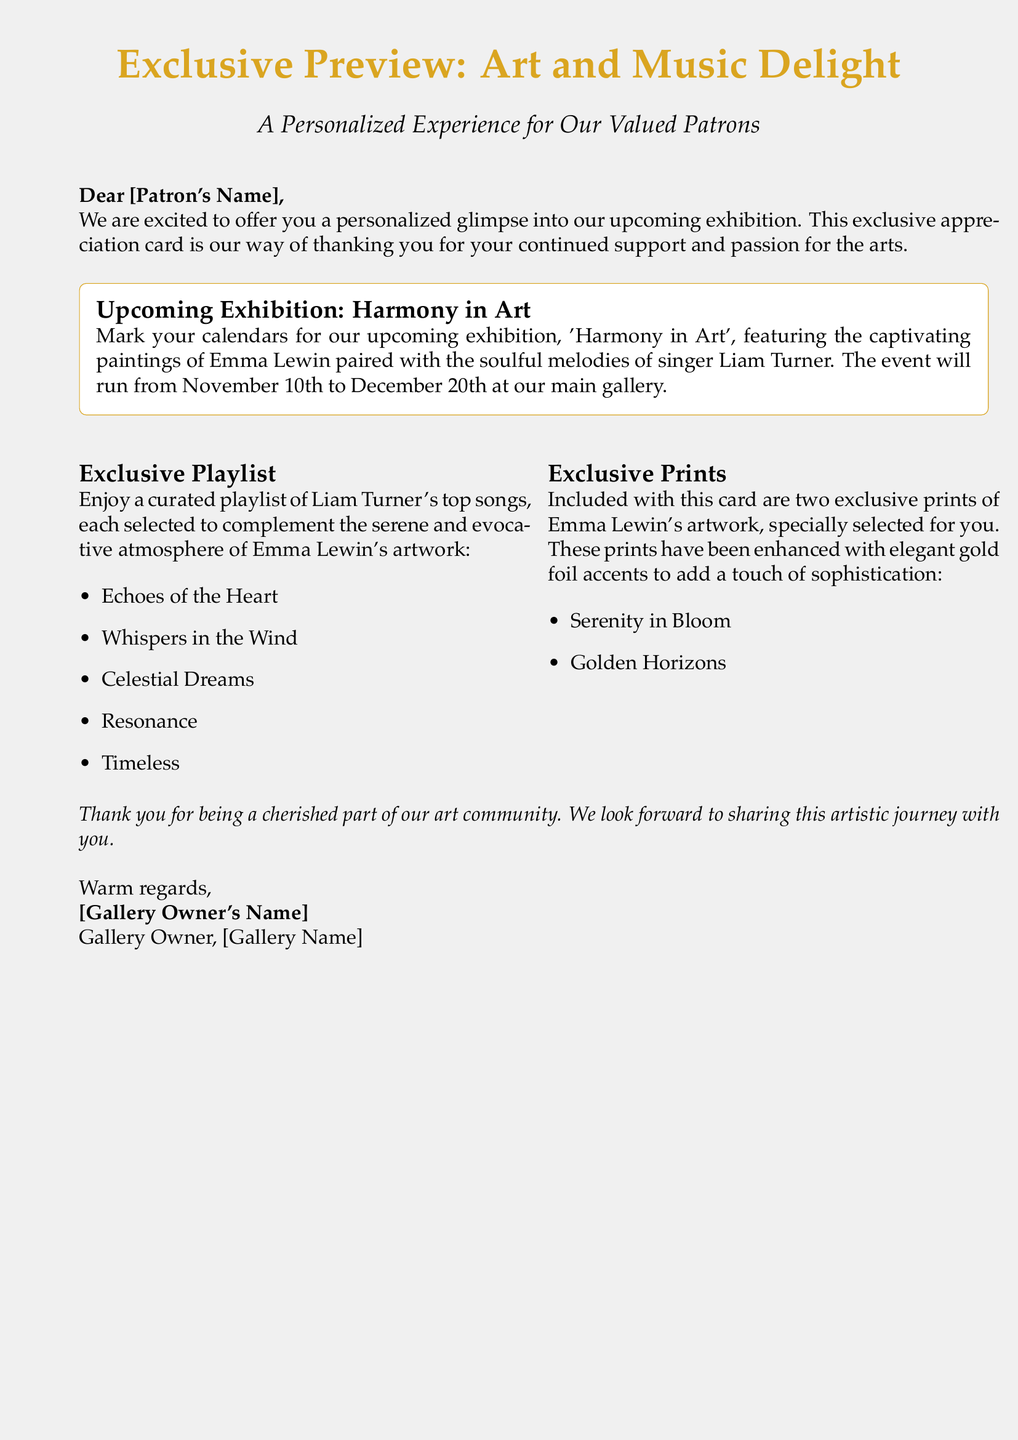What is the name of the upcoming exhibition? The name of the upcoming exhibition is stated as 'Harmony in Art' in the document.
Answer: Harmony in Art What are the dates for the exhibition? The document mentions that the exhibition will run from November 10th to December 20th.
Answer: November 10th to December 20th Who is the painter featured in the exhibition? The painter featured in the exhibition is identified as Emma Lewin in the document.
Answer: Emma Lewin What is the title of one song from the exclusive playlist? The document lists several songs, one of which is 'Echoes of the Heart.'
Answer: Echoes of the Heart How many exclusive prints are included with the card? The document states that two exclusive prints are included with the card.
Answer: Two What type of accents enhance the exclusive prints? The document specifies that the exclusive prints are enhanced with elegant gold foil accents.
Answer: Gold foil accents What is the purpose of this card? The document indicates the card serves as a way to thank patrons for their support and passion for the arts.
Answer: To thank patrons Who is the singer featured alongside the painter's artwork? The singer mentioned in the document is Liam Turner.
Answer: Liam Turner What is the name of the gallery owner? The document mentions that the gallery owner signs off without providing a name in the given content.
Answer: [Gallery Owner's Name] 